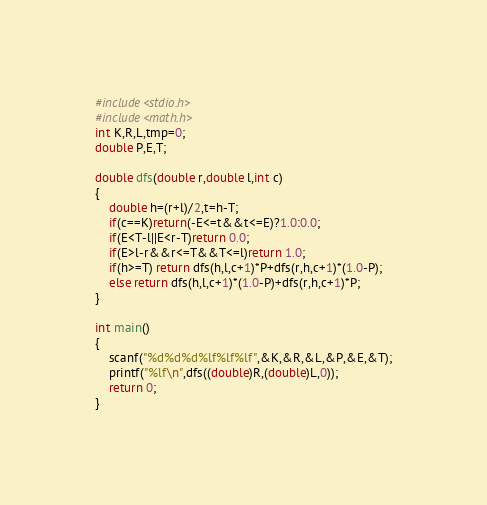<code> <loc_0><loc_0><loc_500><loc_500><_C_>#include<stdio.h>
#include<math.h>
int K,R,L,tmp=0;
double P,E,T;

double dfs(double r,double l,int c)
{
	double h=(r+l)/2,t=h-T;
	if(c==K)return(-E<=t&&t<=E)?1.0:0.0;
	if(E<T-l||E<r-T)return 0.0;
	if(E>l-r&&r<=T&&T<=l)return 1.0;
	if(h>=T) return dfs(h,l,c+1)*P+dfs(r,h,c+1)*(1.0-P);
	else return dfs(h,l,c+1)*(1.0-P)+dfs(r,h,c+1)*P;
}

int main()
{
	scanf("%d%d%d%lf%lf%lf",&K,&R,&L,&P,&E,&T);
	printf("%lf\n",dfs((double)R,(double)L,0));
	return 0;
}</code> 